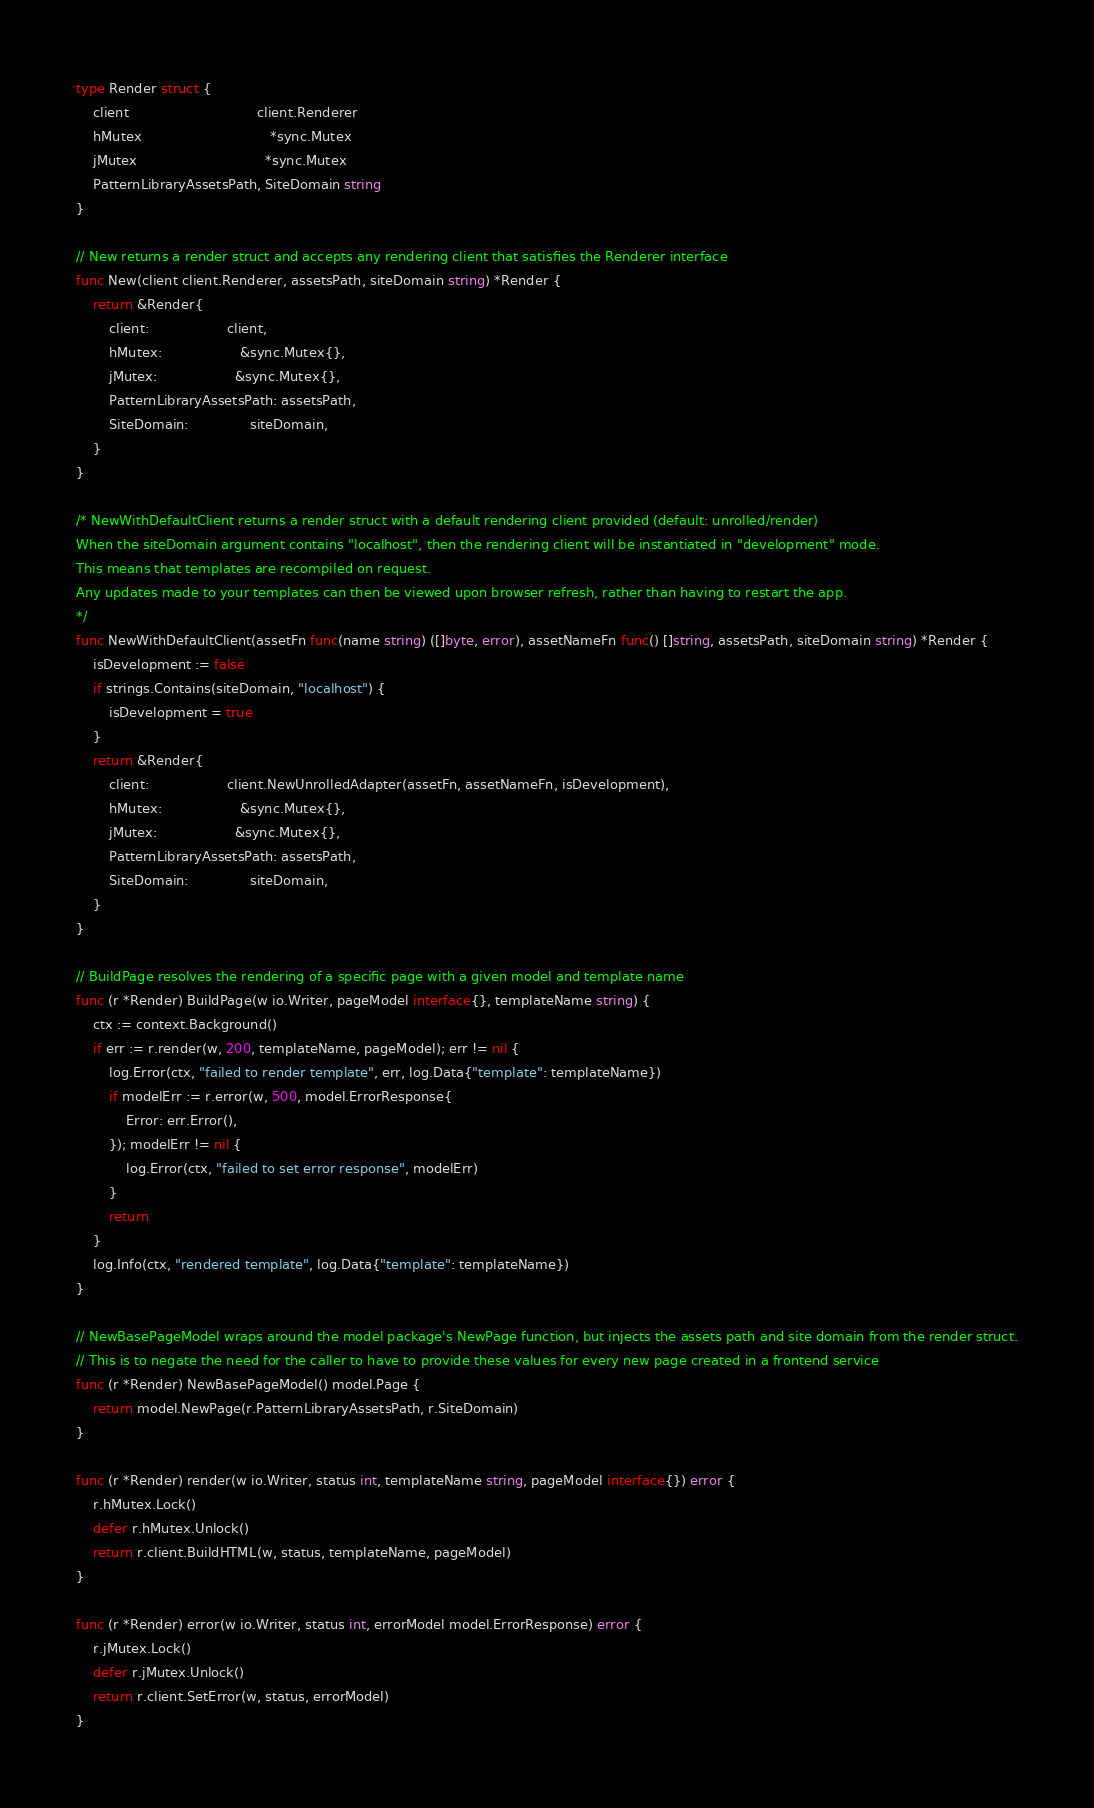<code> <loc_0><loc_0><loc_500><loc_500><_Go_>type Render struct {
	client                               client.Renderer
	hMutex                               *sync.Mutex
	jMutex                               *sync.Mutex
	PatternLibraryAssetsPath, SiteDomain string
}

// New returns a render struct and accepts any rendering client that satisfies the Renderer interface
func New(client client.Renderer, assetsPath, siteDomain string) *Render {
	return &Render{
		client:                   client,
		hMutex:                   &sync.Mutex{},
		jMutex:                   &sync.Mutex{},
		PatternLibraryAssetsPath: assetsPath,
		SiteDomain:               siteDomain,
	}
}

/* NewWithDefaultClient returns a render struct with a default rendering client provided (default: unrolled/render)
When the siteDomain argument contains "localhost", then the rendering client will be instantiated in "development" mode.
This means that templates are recompiled on request.
Any updates made to your templates can then be viewed upon browser refresh, rather than having to restart the app.
*/
func NewWithDefaultClient(assetFn func(name string) ([]byte, error), assetNameFn func() []string, assetsPath, siteDomain string) *Render {
	isDevelopment := false
	if strings.Contains(siteDomain, "localhost") {
		isDevelopment = true
	}
	return &Render{
		client:                   client.NewUnrolledAdapter(assetFn, assetNameFn, isDevelopment),
		hMutex:                   &sync.Mutex{},
		jMutex:                   &sync.Mutex{},
		PatternLibraryAssetsPath: assetsPath,
		SiteDomain:               siteDomain,
	}
}

// BuildPage resolves the rendering of a specific page with a given model and template name
func (r *Render) BuildPage(w io.Writer, pageModel interface{}, templateName string) {
	ctx := context.Background()
	if err := r.render(w, 200, templateName, pageModel); err != nil {
		log.Error(ctx, "failed to render template", err, log.Data{"template": templateName})
		if modelErr := r.error(w, 500, model.ErrorResponse{
			Error: err.Error(),
		}); modelErr != nil {
			log.Error(ctx, "failed to set error response", modelErr)
		}
		return
	}
	log.Info(ctx, "rendered template", log.Data{"template": templateName})
}

// NewBasePageModel wraps around the model package's NewPage function, but injects the assets path and site domain from the render struct.
// This is to negate the need for the caller to have to provide these values for every new page created in a frontend service
func (r *Render) NewBasePageModel() model.Page {
	return model.NewPage(r.PatternLibraryAssetsPath, r.SiteDomain)
}

func (r *Render) render(w io.Writer, status int, templateName string, pageModel interface{}) error {
	r.hMutex.Lock()
	defer r.hMutex.Unlock()
	return r.client.BuildHTML(w, status, templateName, pageModel)
}

func (r *Render) error(w io.Writer, status int, errorModel model.ErrorResponse) error {
	r.jMutex.Lock()
	defer r.jMutex.Unlock()
	return r.client.SetError(w, status, errorModel)
}
</code> 